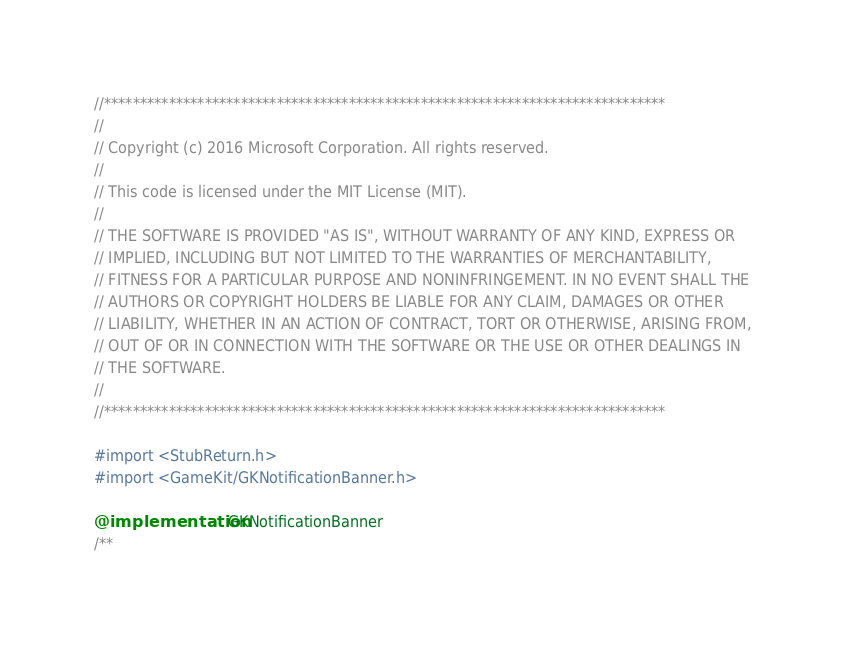<code> <loc_0><loc_0><loc_500><loc_500><_ObjectiveC_>//******************************************************************************
//
// Copyright (c) 2016 Microsoft Corporation. All rights reserved.
//
// This code is licensed under the MIT License (MIT).
//
// THE SOFTWARE IS PROVIDED "AS IS", WITHOUT WARRANTY OF ANY KIND, EXPRESS OR
// IMPLIED, INCLUDING BUT NOT LIMITED TO THE WARRANTIES OF MERCHANTABILITY,
// FITNESS FOR A PARTICULAR PURPOSE AND NONINFRINGEMENT. IN NO EVENT SHALL THE
// AUTHORS OR COPYRIGHT HOLDERS BE LIABLE FOR ANY CLAIM, DAMAGES OR OTHER
// LIABILITY, WHETHER IN AN ACTION OF CONTRACT, TORT OR OTHERWISE, ARISING FROM,
// OUT OF OR IN CONNECTION WITH THE SOFTWARE OR THE USE OR OTHER DEALINGS IN
// THE SOFTWARE.
//
//******************************************************************************

#import <StubReturn.h>
#import <GameKit/GKNotificationBanner.h>

@implementation GKNotificationBanner
/**</code> 